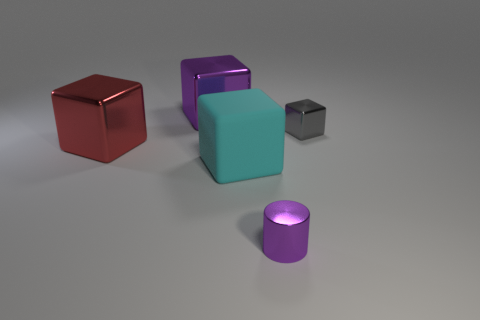There is a gray block; are there any large blocks in front of it?
Offer a terse response. Yes. Do the large purple thing and the object to the right of the small cylinder have the same material?
Give a very brief answer. Yes. Is the shape of the purple object that is in front of the red block the same as  the gray shiny object?
Give a very brief answer. No. What number of blue balls are made of the same material as the tiny gray block?
Provide a succinct answer. 0. What number of things are purple metal objects in front of the tiny gray shiny block or tiny brown metal cylinders?
Your answer should be compact. 1. What is the size of the cyan block?
Offer a terse response. Large. There is a big block behind the gray metal block behind the tiny purple metallic thing; what is its material?
Keep it short and to the point. Metal. There is a shiny block that is in front of the gray metal thing; does it have the same size as the large cyan rubber thing?
Offer a very short reply. Yes. Is there a tiny thing of the same color as the small cylinder?
Provide a short and direct response. No. How many objects are either metallic cubes that are behind the red shiny block or cubes on the left side of the purple block?
Your answer should be very brief. 3. 